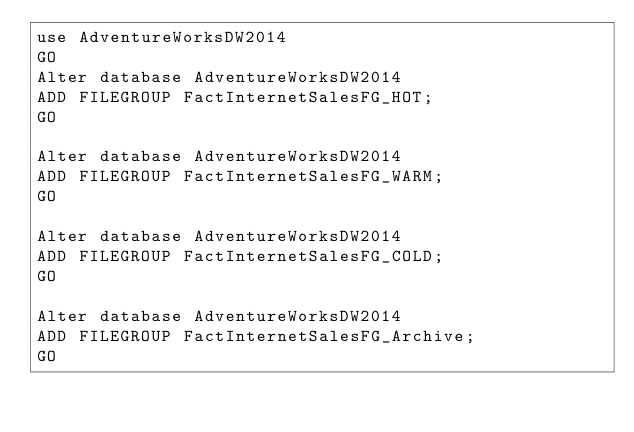<code> <loc_0><loc_0><loc_500><loc_500><_SQL_>use AdventureWorksDW2014
GO
Alter database AdventureWorksDW2014
ADD FILEGROUP FactInternetSalesFG_HOT;
GO

Alter database AdventureWorksDW2014
ADD FILEGROUP FactInternetSalesFG_WARM;
GO

Alter database AdventureWorksDW2014
ADD FILEGROUP FactInternetSalesFG_COLD;
GO

Alter database AdventureWorksDW2014
ADD FILEGROUP FactInternetSalesFG_Archive;
GO


</code> 